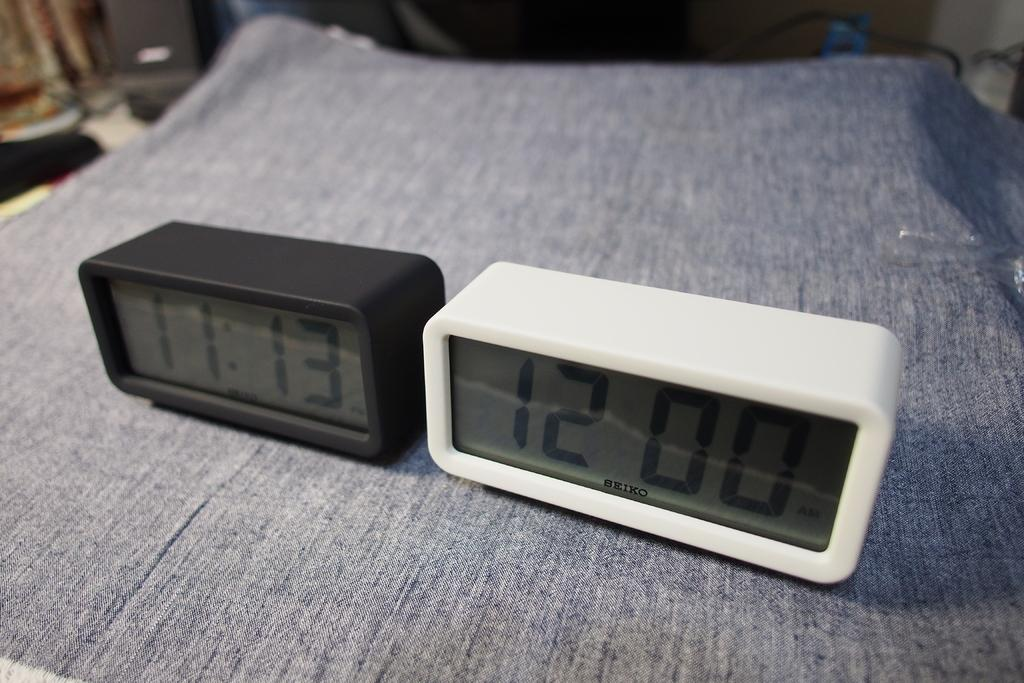<image>
Give a short and clear explanation of the subsequent image. One black and one white Seiko digital clock on a gray surface 